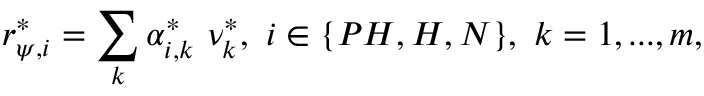Convert formula to latex. <formula><loc_0><loc_0><loc_500><loc_500>r _ { \psi , i } ^ { * } = \sum _ { k } \alpha _ { i , k } ^ { * } \ \nu _ { k } ^ { * } , \ i \in \{ P H , H , N \} , \ k = 1 , \dots , m ,</formula> 